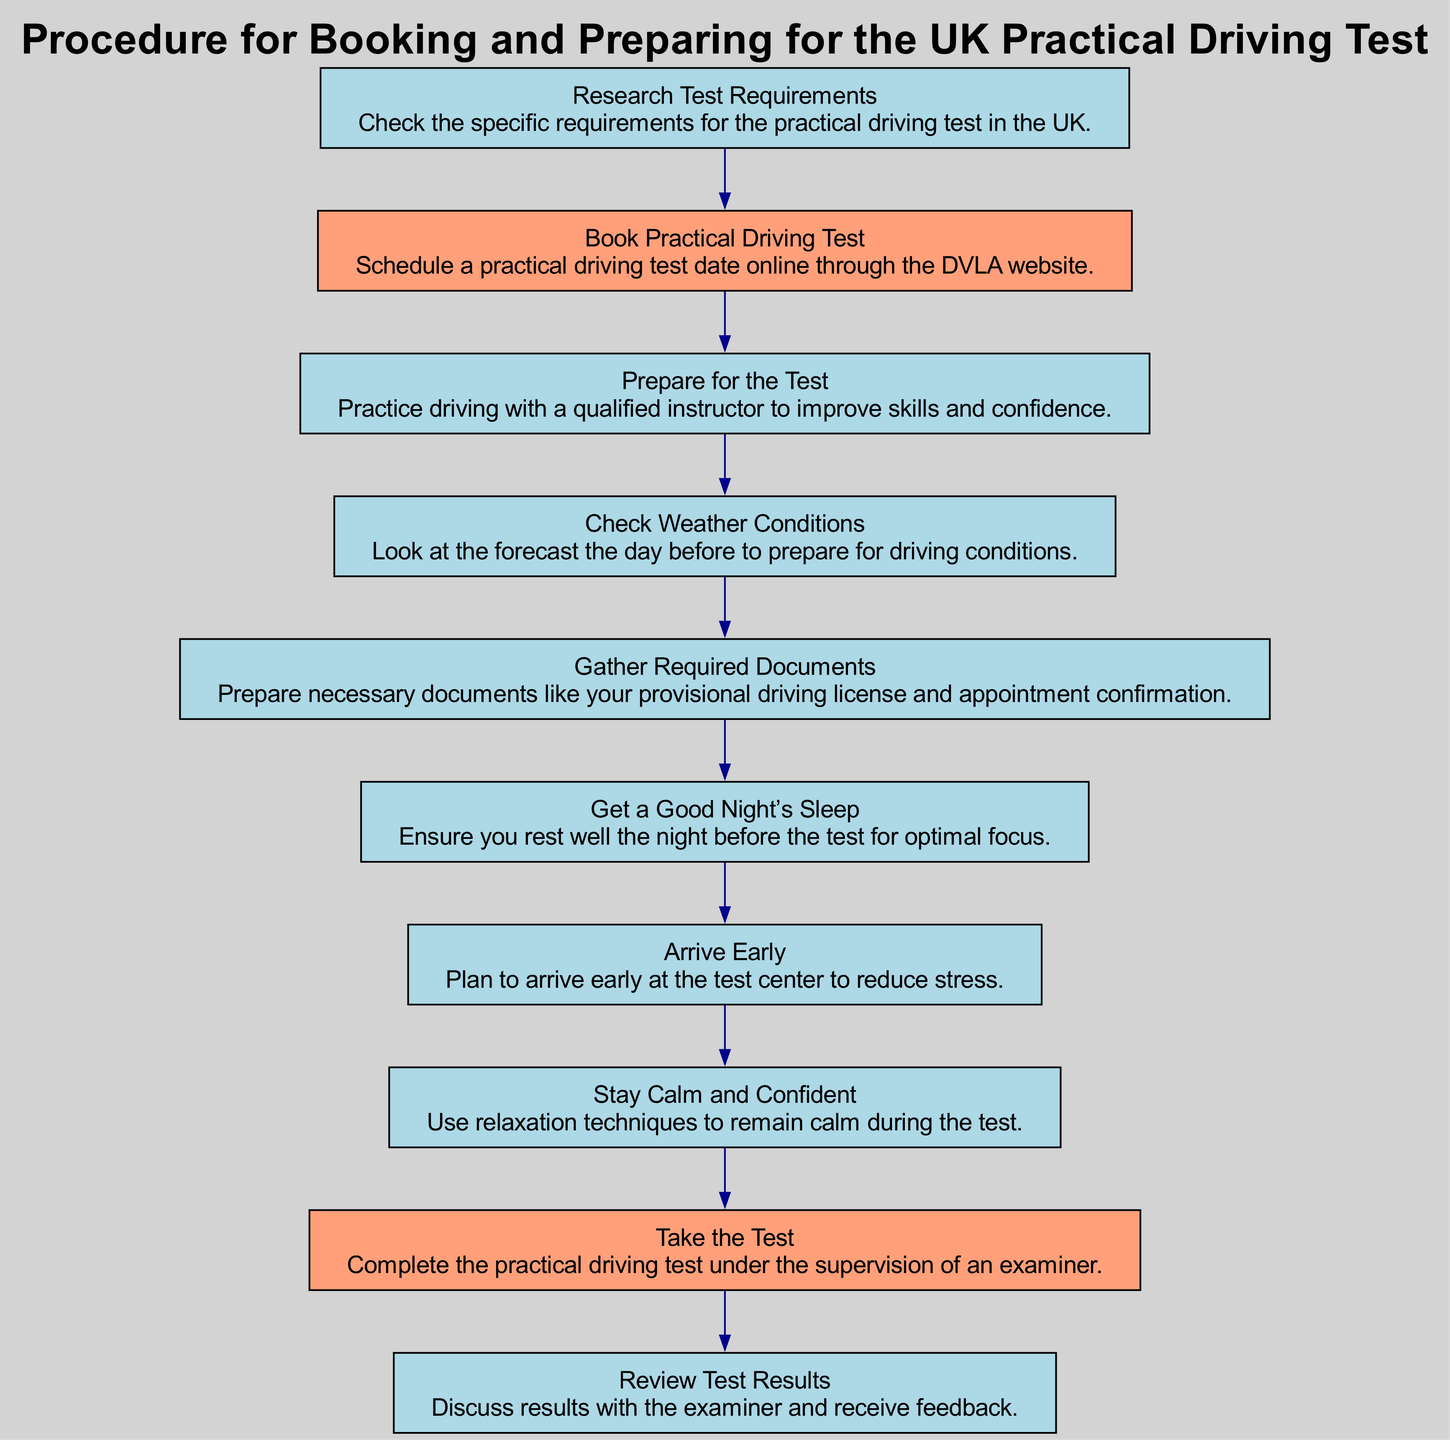What is the first step in the practical driving test procedure? According to the flow chart, the first step is "Research Test Requirements," which involves checking the specific requirements for the practical driving test in the UK.
Answer: Research Test Requirements How many nodes are in the diagram? By counting the individual steps or elements listed in the diagram, there are a total of 10 nodes, including all the preparation steps and the test process itself.
Answer: 10 Which step directly follows "Book Practical Driving Test"? In the sequence of the flow chart, "Prepare for the Test" is the step that comes directly after "Book Practical Driving Test.”
Answer: Prepare for the Test What step is highlighted as important in the flow chart? The steps "Book Practical Driving Test" and "Take the Test" are both highlighted in different colors (lightsalmon), which indicates they are considered important in the overall procedure.
Answer: Book Practical Driving Test, Take the Test What is the last step in the process? The final step in the flow chart is "Review Test Results," where the test results are discussed with the examiner and feedback is received.
Answer: Review Test Results What should you do the night before the driving test? The diagram specifies that you should "Get a Good Night’s Sleep" to ensure optimal focus for the day of the test.
Answer: Get a Good Night’s Sleep How many steps involve preparation for the driving test? There are four distinct steps focused on preparation, which are "Prepare for the Test," "Check Weather Conditions," "Gather Required Documents," and "Get a Good Night’s Sleep."
Answer: 4 What is the purpose of "Stay Calm and Confident" in the flow chart? This step emphasizes using relaxation techniques to maintain composure during the test, indicating its significance in achieving a successful outcome.
Answer: To remain calm during the test 